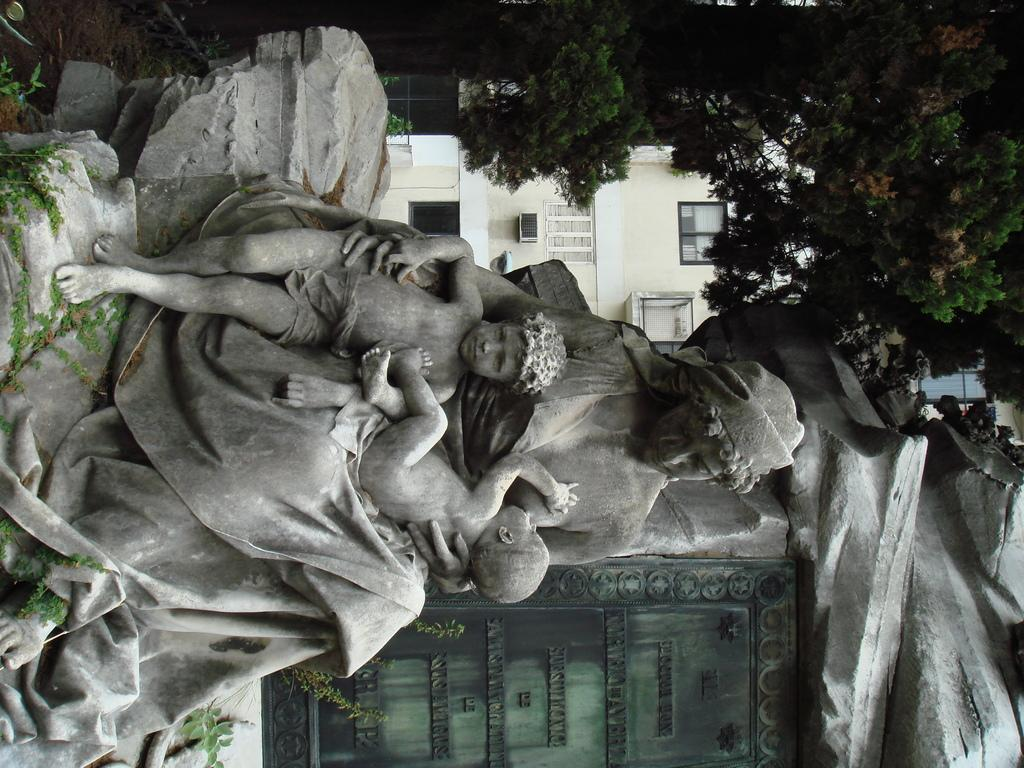What is the main subject of the image? There is a statue of a woman in the image. What is the woman in the statue doing? The woman has two kids on her lap. What can be seen in the background of the image? There are trees at the top of the image and a building with windows behind the statue. What language is the crook speaking to the kids in the image? There is no crook or any person speaking in the image; it features a statue of a woman with two kids on her lap. What type of yoke is the woman using to carry the kids in the image? The woman in the statue is not using a yoke to carry the kids; she has them on her lap. 